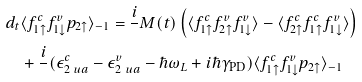Convert formula to latex. <formula><loc_0><loc_0><loc_500><loc_500>d _ { t } & \langle f ^ { c } _ { 1 \uparrow } f ^ { v } _ { 1 \downarrow } p _ { 2 \uparrow } \rangle _ { - 1 } = \frac { i } { } M ( t ) \left ( \langle f ^ { c } _ { 1 \uparrow } f ^ { v } _ { 2 \uparrow } f ^ { v } _ { 1 \downarrow } \rangle - \langle f ^ { c } _ { 2 \uparrow } f ^ { c } _ { 1 \uparrow } f ^ { v } _ { 1 \downarrow } \rangle \right ) \\ & + \frac { i } { } ( \epsilon ^ { c } _ { 2 \ u a } - \epsilon ^ { v } _ { 2 \ u a } - \hbar { \omega } _ { L } + i \hbar { \gamma } _ { \text {PD} } ) \langle f ^ { c } _ { 1 \uparrow } f ^ { v } _ { 1 \downarrow } p _ { 2 \uparrow } \rangle _ { - 1 }</formula> 